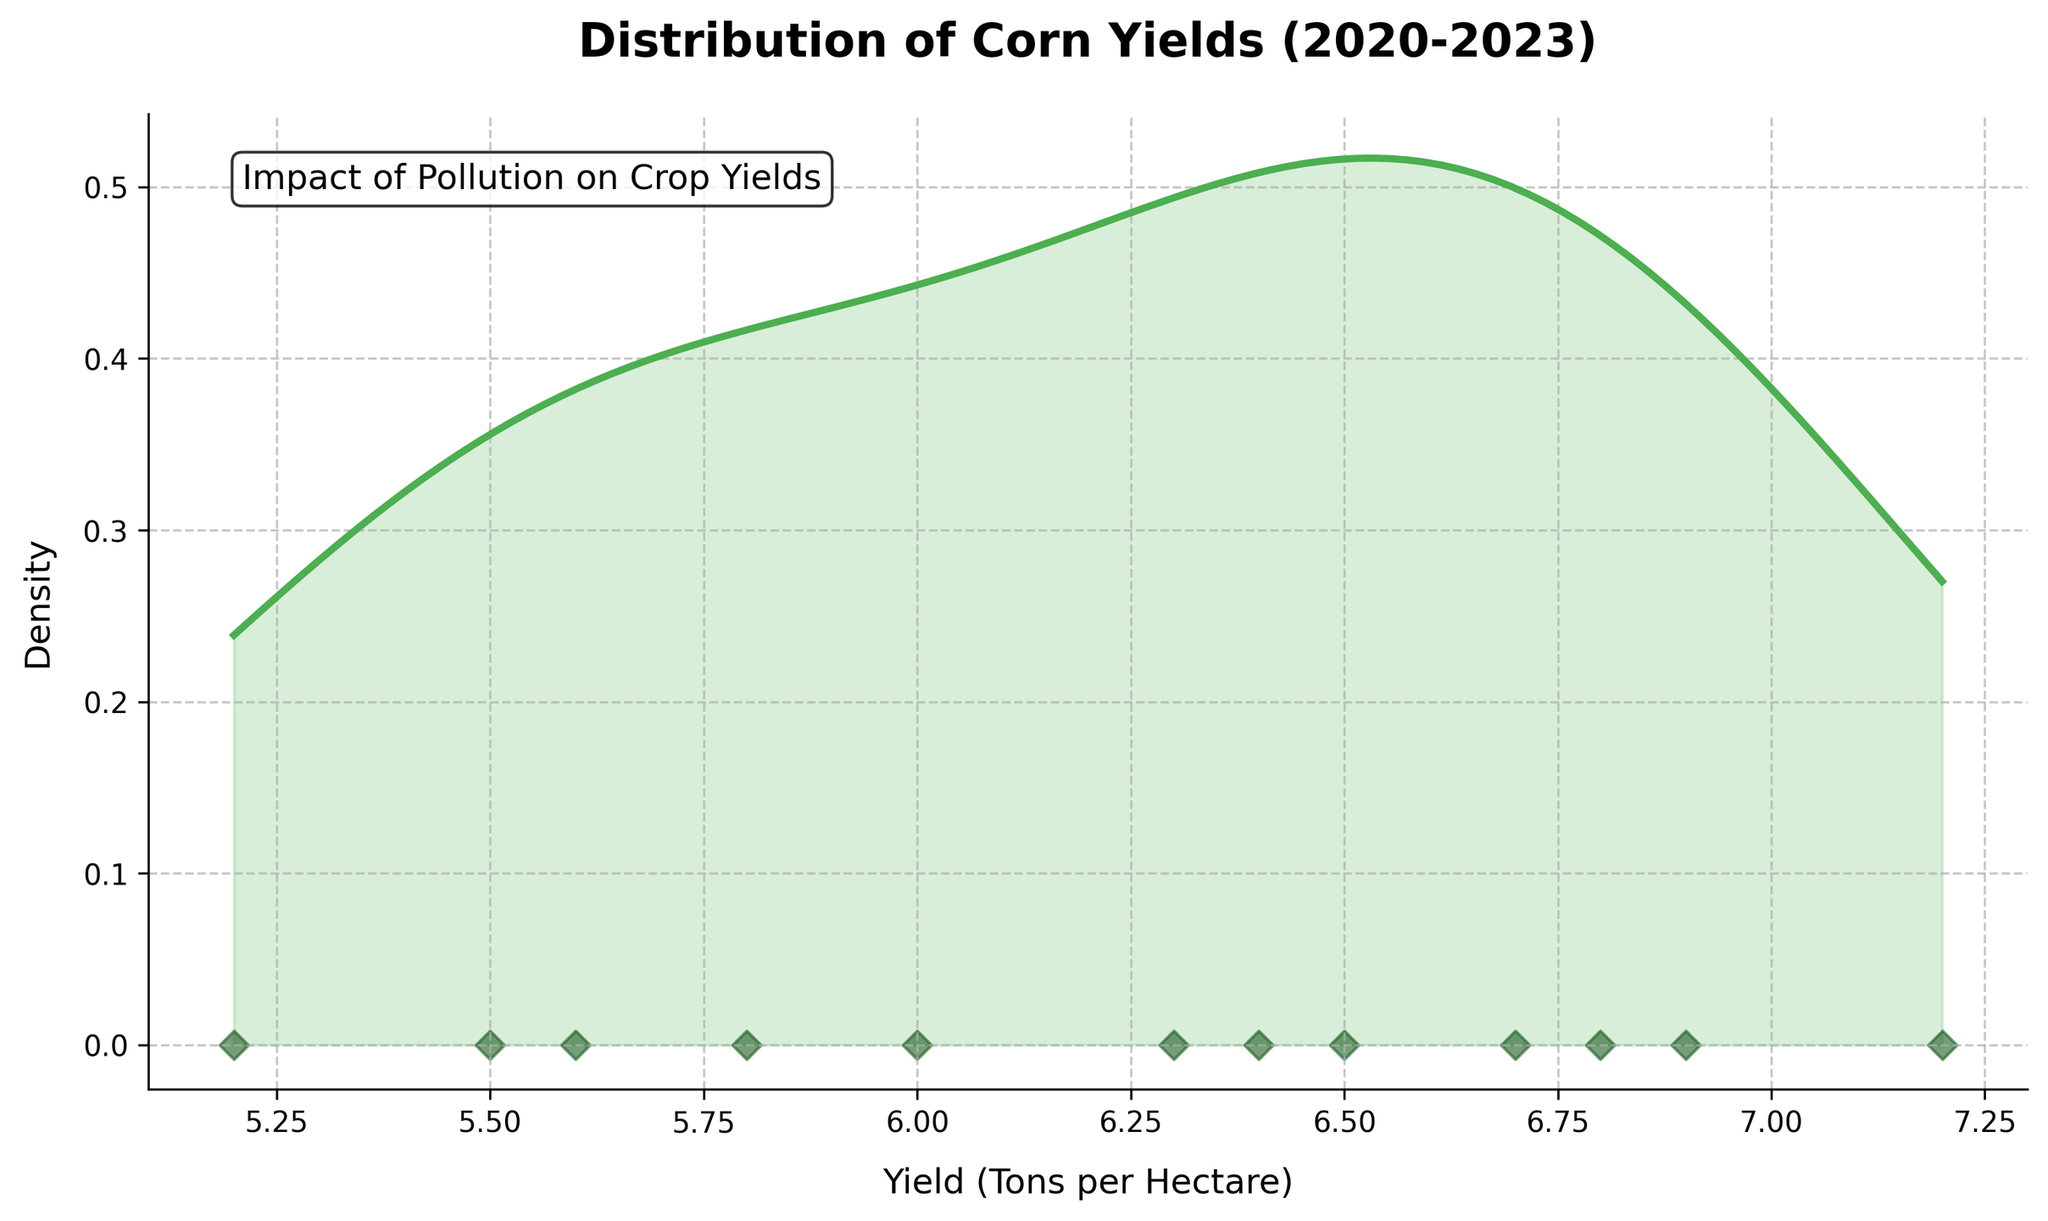How many seasons are represented in the figure? Count the number of distinct data points on the scatter plot below the density curve to determine the number of seasons.
Answer: 12 What is the title of the figure? Look at the text at the top of the plot, which serves as the title.
Answer: Distribution of Corn Yields (2020-2023) What is the range of corn yields shown in the figure? Examine the x-axis for the minimum and maximum values, which represent the range of yields.
Answer: 5.2 to 7.2 Tons per Hectare What's the densest value of the corn yield distribution? Identify the peak of the density curve, which indicates the most frequent yield value.
Answer: Around 6.5 Tons per Hectare Does the plot suggest a trend in corn yields as pollution levels increase? Observe the scatter plot points' arrangement against the yield values and compare this with the expected range of pollution levels over the seasons in the provided data. The yields decrease as the seasons progress, correlating with higher pollution levels.
Answer: Yes, yields decrease with higher pollution levels Which corn yield values show the most significant decline when pollution levels are extreme? Find the lowest points in the scatter plot and match them with corresponding extreme pollution levels.
Answer: 5.2, 5.5, 5.6 Tons per Hectare What are the lowest and highest densities represented in the plot? Check the y-axis for the minimum and maximum values on the density curve.
Answer: 0 at the lowest point, and the peak's value at the highest How does the yield in Spring 2023 compare with Fall 2023? Compare the x-axis positions of the data points specific to Spring 2023 and Fall 2023.
Answer: Spring 2023 yield (6.4) is higher than Fall 2023 yield (5.2) What textual annotation is included in the plot and where is it located? Look for any text within the plot area and note its content and position.
Answer: "Impact of Pollution on Crop Yields" located at the top-left corner What's the average corn yield across all seasons? Add up all the individual yield values and divide by the total number of data points. (7.2+6.8+6.5+6.9+6.3+6.0+6.7+5.8+5.5+6.4+5.6+5.2) / 12 = 6.26
Answer: 6.26 Tons per Hectare 